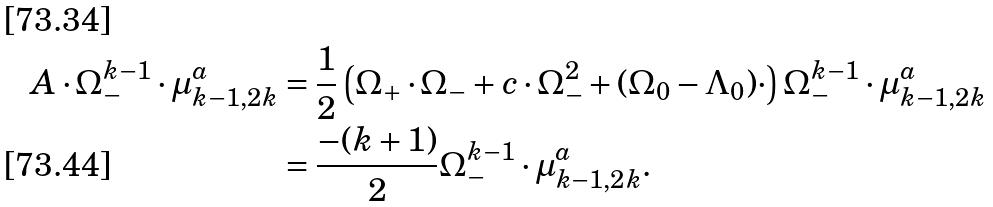<formula> <loc_0><loc_0><loc_500><loc_500>A \cdot \Omega _ { - } ^ { k - 1 } \cdot \mu _ { k - 1 , 2 k } ^ { a } & = \frac { 1 } { 2 } \left ( \Omega _ { + } \cdot \Omega _ { - } + c \cdot \Omega _ { - } ^ { 2 } + ( \Omega _ { 0 } - \Lambda _ { 0 } ) \cdot \right ) \Omega _ { - } ^ { k - 1 } \cdot \mu _ { k - 1 , 2 k } ^ { a } \\ & = \frac { - ( k + 1 ) } { 2 } \Omega _ { - } ^ { k - 1 } \cdot \mu _ { k - 1 , 2 k } ^ { a } .</formula> 